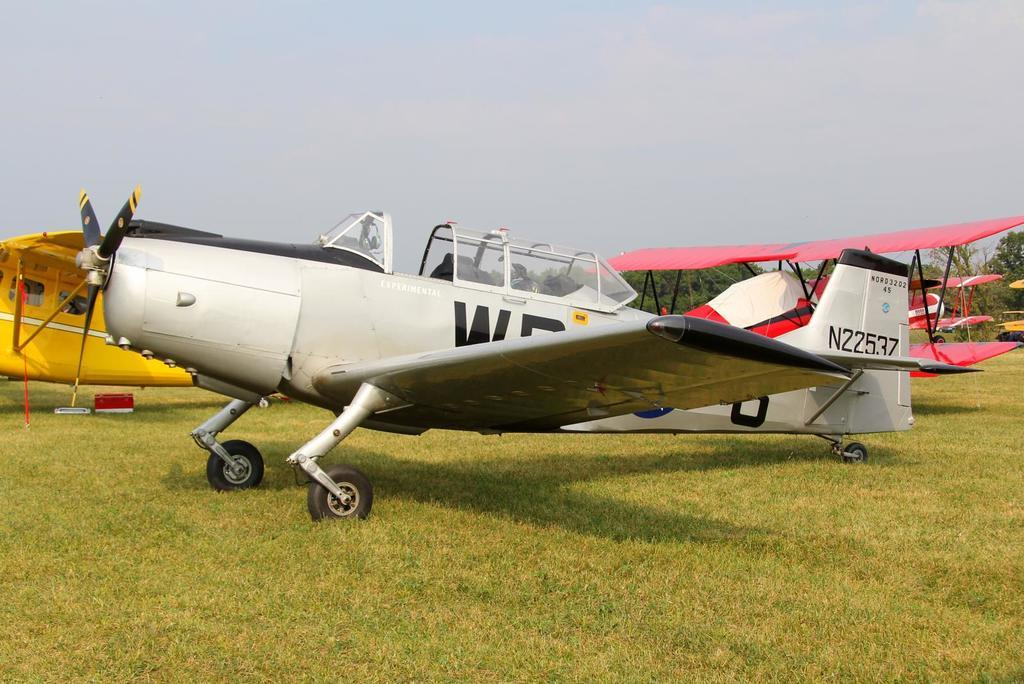<image>
Present a compact description of the photo's key features. A grey small plane that says N22537 on the tail. 